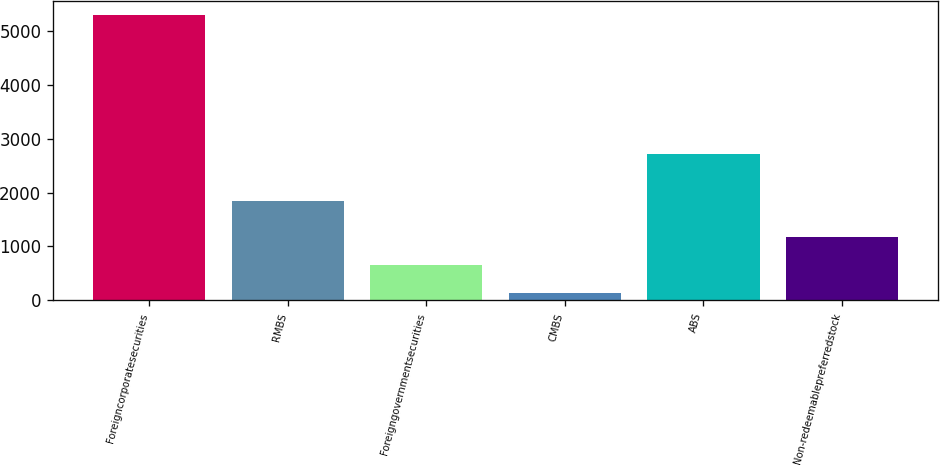<chart> <loc_0><loc_0><loc_500><loc_500><bar_chart><fcel>Foreigncorporatesecurities<fcel>RMBS<fcel>Foreigngovernmentsecurities<fcel>CMBS<fcel>ABS<fcel>Non-redeemablepreferredstock<nl><fcel>5292<fcel>1840<fcel>654.3<fcel>139<fcel>2712<fcel>1169.6<nl></chart> 